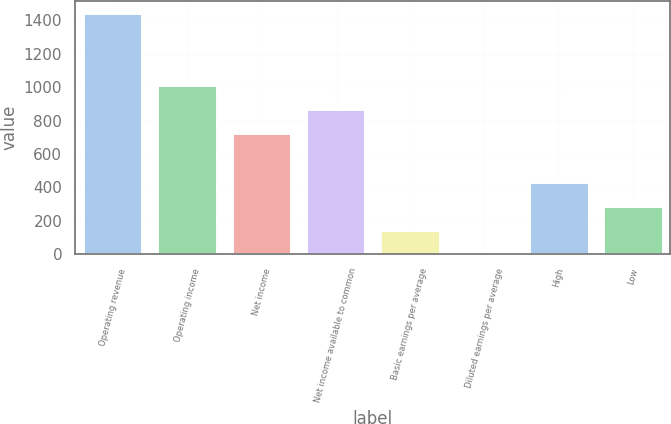Convert chart. <chart><loc_0><loc_0><loc_500><loc_500><bar_chart><fcel>Operating revenue<fcel>Operating income<fcel>Net income<fcel>Net income available to common<fcel>Basic earnings per average<fcel>Diluted earnings per average<fcel>High<fcel>Low<nl><fcel>1445<fcel>1011.61<fcel>722.71<fcel>867.16<fcel>144.91<fcel>0.46<fcel>433.81<fcel>289.36<nl></chart> 